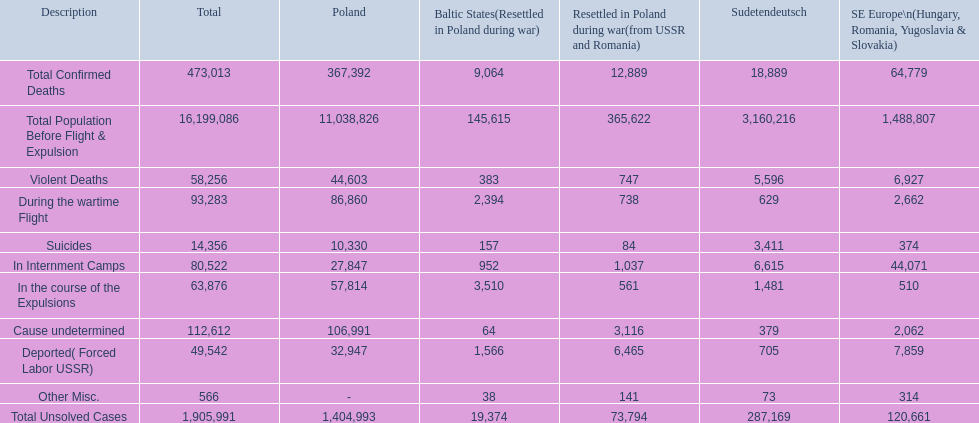How many total confirmed deaths were there in the baltic states? 9,064. How many deaths had an undetermined cause? 64. How many deaths in that region were miscellaneous? 38. Were there more deaths from an undetermined cause or that were listed as miscellaneous? Cause undetermined. 